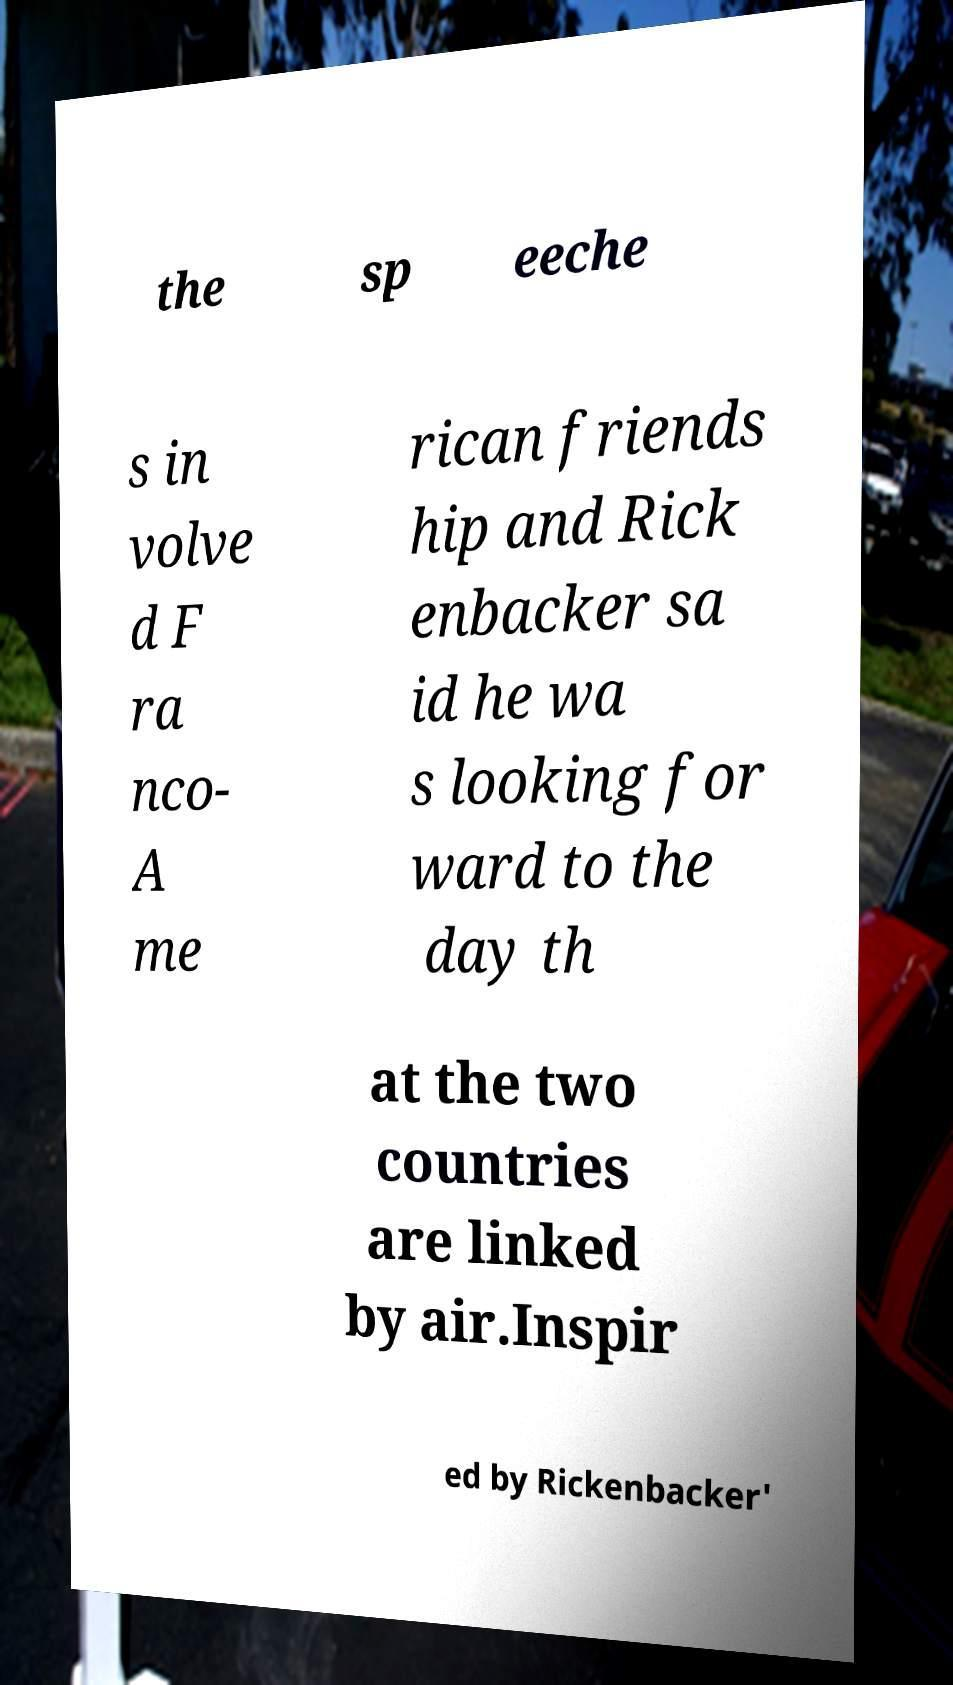I need the written content from this picture converted into text. Can you do that? the sp eeche s in volve d F ra nco- A me rican friends hip and Rick enbacker sa id he wa s looking for ward to the day th at the two countries are linked by air.Inspir ed by Rickenbacker' 